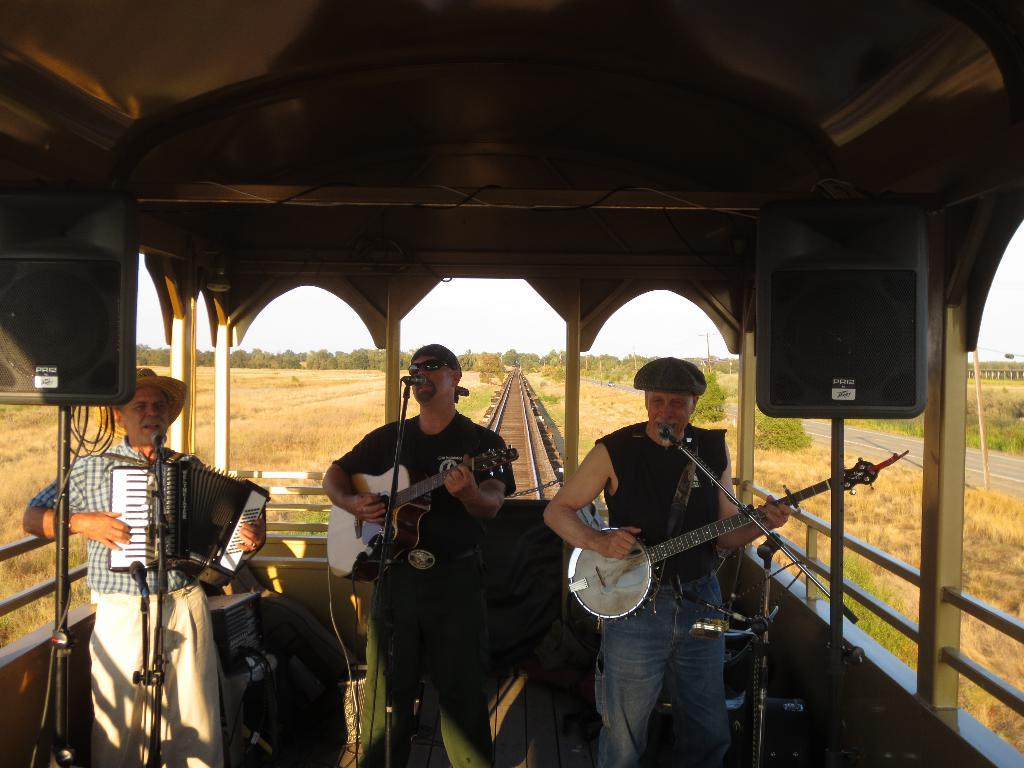How many people are in the image? There are three men in the image. What are the men doing in the image? The men are traveling on a moving track, singing on a microphone, and playing musical instruments. What type of square can be seen in the image? There is no square present in the image. How does the curve affect the men's performance in the image? There is no curve mentioned in the image, so it cannot affect the men's performance. 